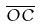Convert formula to latex. <formula><loc_0><loc_0><loc_500><loc_500>\overline { O C }</formula> 